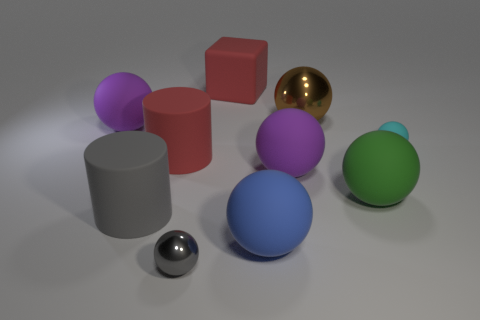What is the material of the big cylinder that is the same color as the rubber cube?
Your answer should be very brief. Rubber. There is a small rubber object; is its color the same as the metallic sphere that is in front of the cyan ball?
Your answer should be compact. No. Are there more red spheres than large gray things?
Offer a very short reply. No. There is a green matte thing that is the same shape as the cyan object; what is its size?
Ensure brevity in your answer.  Large. Are the green thing and the gray thing that is in front of the big gray cylinder made of the same material?
Your response must be concise. No. How many things are either small blue objects or big red rubber objects?
Give a very brief answer. 2. There is a purple rubber object that is behind the big red rubber cylinder; does it have the same size as the metallic ball that is to the right of the red block?
Your answer should be very brief. Yes. What number of cylinders are either large brown metallic things or big green things?
Ensure brevity in your answer.  0. Are any brown cubes visible?
Make the answer very short. No. Are there any other things that are the same shape as the gray metal thing?
Make the answer very short. Yes. 